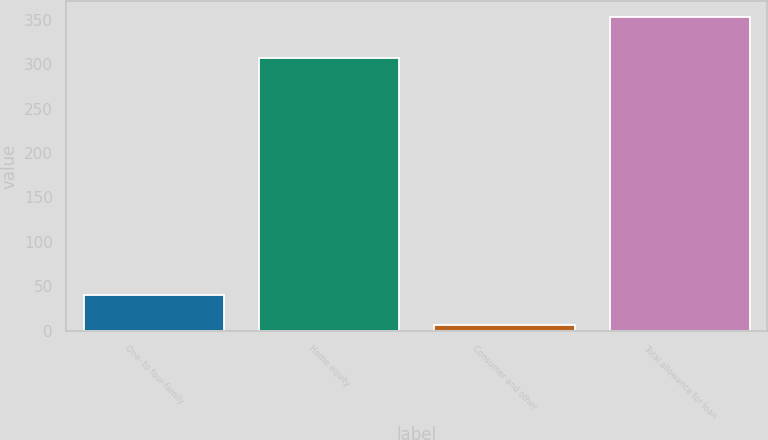<chart> <loc_0><loc_0><loc_500><loc_500><bar_chart><fcel>One- to four-family<fcel>Home equity<fcel>Consumer and other<fcel>Total allowance for loan<nl><fcel>40.7<fcel>307<fcel>6<fcel>353<nl></chart> 